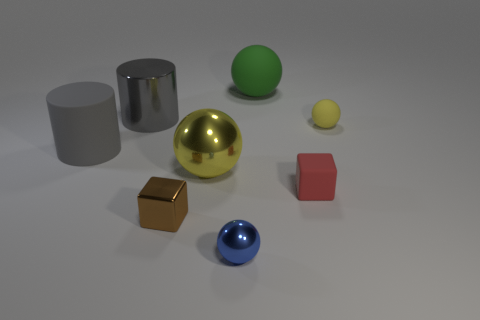Add 1 small cubes. How many objects exist? 9 Subtract all cylinders. How many objects are left? 6 Subtract all shiny cylinders. Subtract all tiny blue metal things. How many objects are left? 6 Add 8 large green rubber balls. How many large green rubber balls are left? 9 Add 6 large metallic things. How many large metallic things exist? 8 Subtract 0 blue cylinders. How many objects are left? 8 